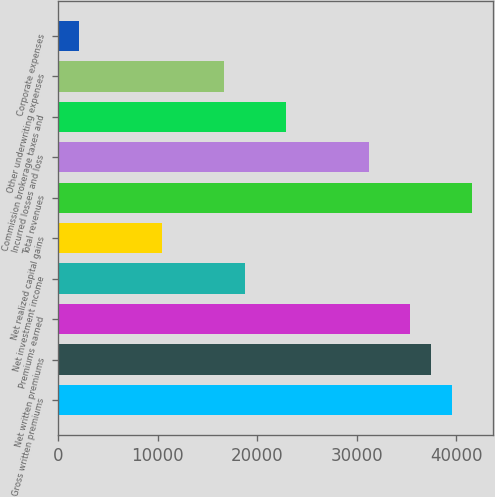<chart> <loc_0><loc_0><loc_500><loc_500><bar_chart><fcel>Gross written premiums<fcel>Net written premiums<fcel>Premiums earned<fcel>Net investment income<fcel>Net realized capital gains<fcel>Total revenues<fcel>Incurred losses and loss<fcel>Commission brokerage taxes and<fcel>Other underwriting expenses<fcel>Corporate expenses<nl><fcel>39534<fcel>37454.4<fcel>35374.9<fcel>18738.2<fcel>10419.9<fcel>41613.6<fcel>31215.7<fcel>22897.4<fcel>16658.6<fcel>2101.58<nl></chart> 